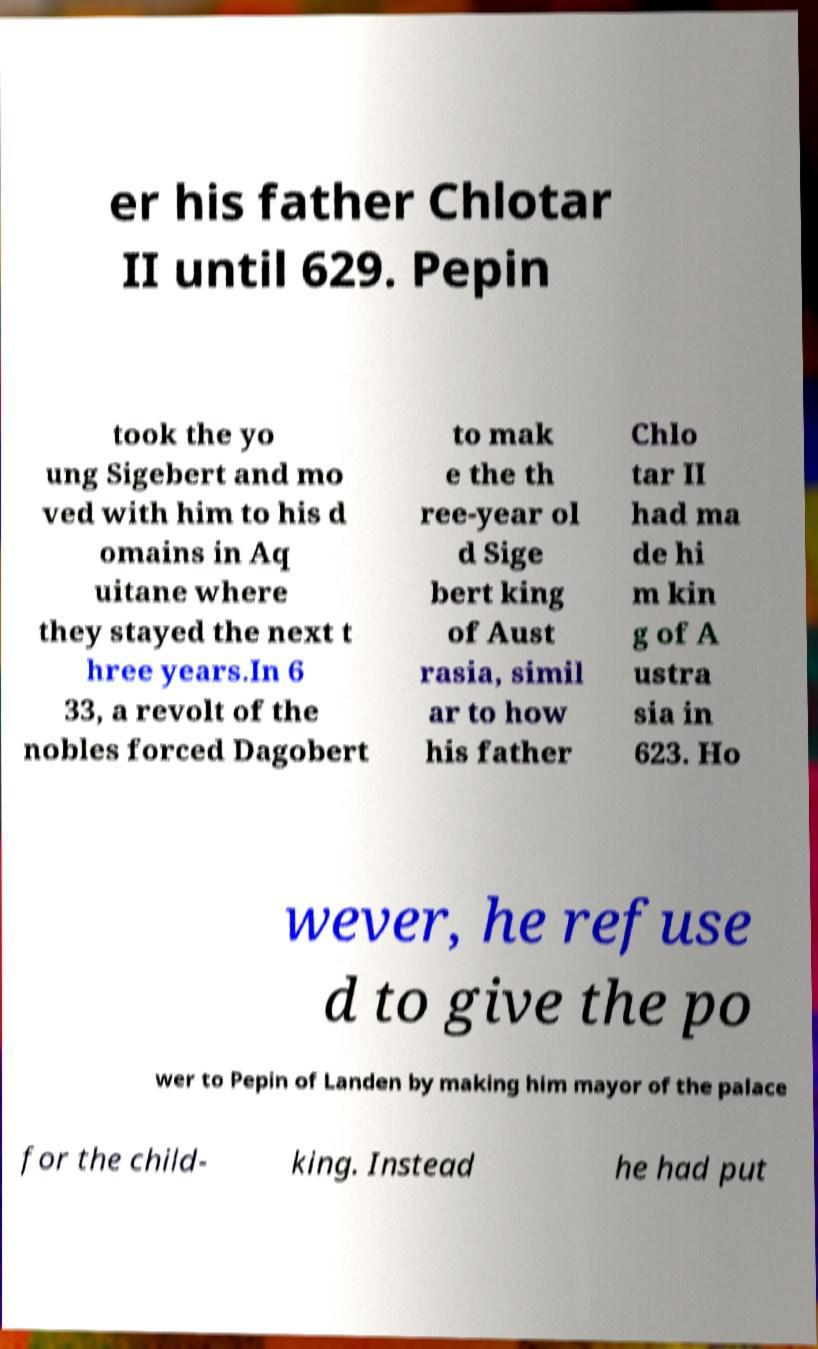For documentation purposes, I need the text within this image transcribed. Could you provide that? er his father Chlotar II until 629. Pepin took the yo ung Sigebert and mo ved with him to his d omains in Aq uitane where they stayed the next t hree years.In 6 33, a revolt of the nobles forced Dagobert to mak e the th ree-year ol d Sige bert king of Aust rasia, simil ar to how his father Chlo tar II had ma de hi m kin g of A ustra sia in 623. Ho wever, he refuse d to give the po wer to Pepin of Landen by making him mayor of the palace for the child- king. Instead he had put 